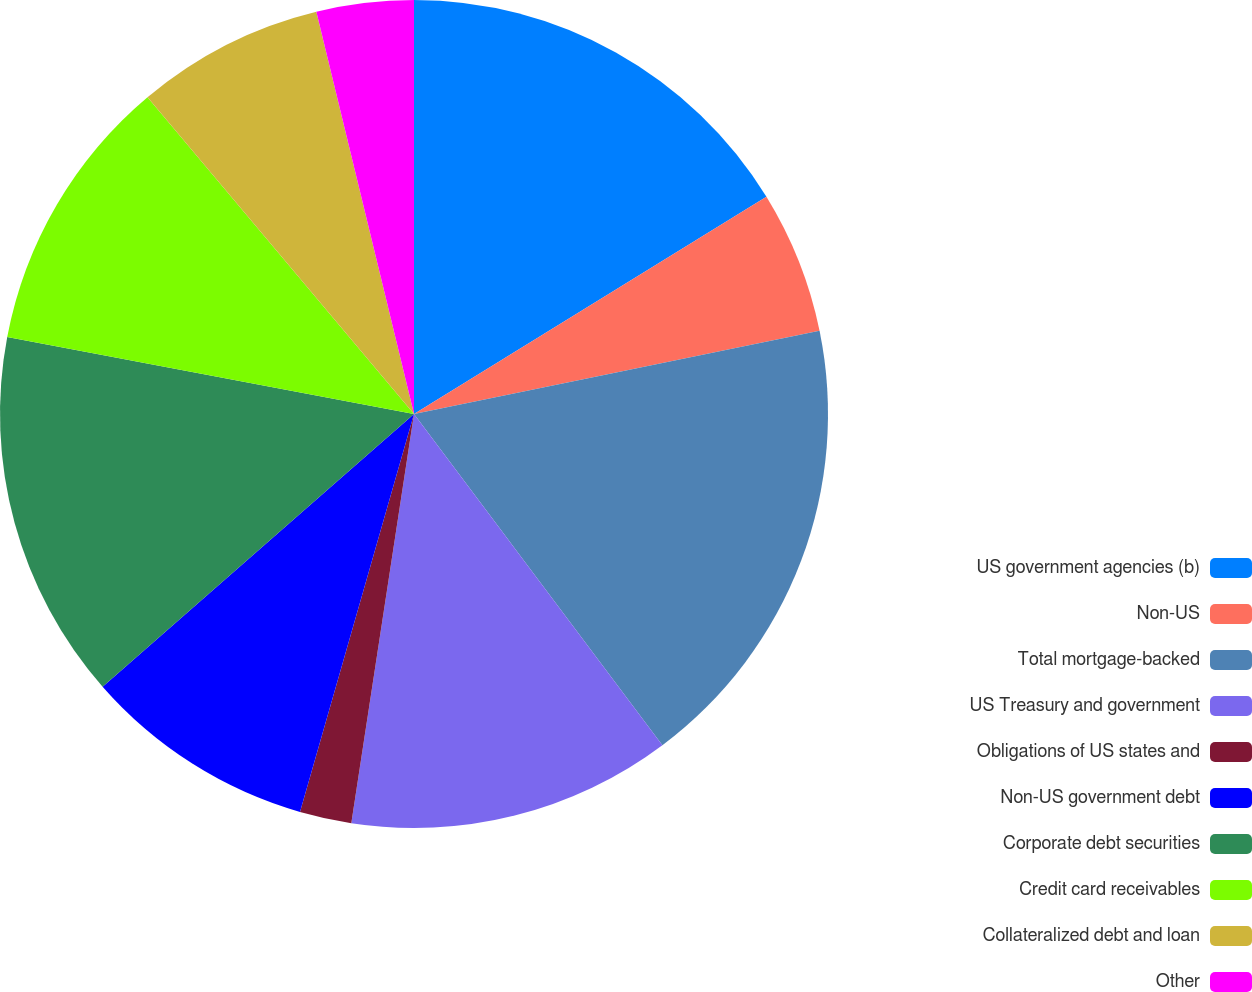Convert chart. <chart><loc_0><loc_0><loc_500><loc_500><pie_chart><fcel>US government agencies (b)<fcel>Non-US<fcel>Total mortgage-backed<fcel>US Treasury and government<fcel>Obligations of US states and<fcel>Non-US government debt<fcel>Corporate debt securities<fcel>Credit card receivables<fcel>Collateralized debt and loan<fcel>Other<nl><fcel>16.21%<fcel>5.57%<fcel>17.98%<fcel>12.66%<fcel>2.02%<fcel>9.11%<fcel>14.43%<fcel>10.89%<fcel>7.34%<fcel>3.79%<nl></chart> 